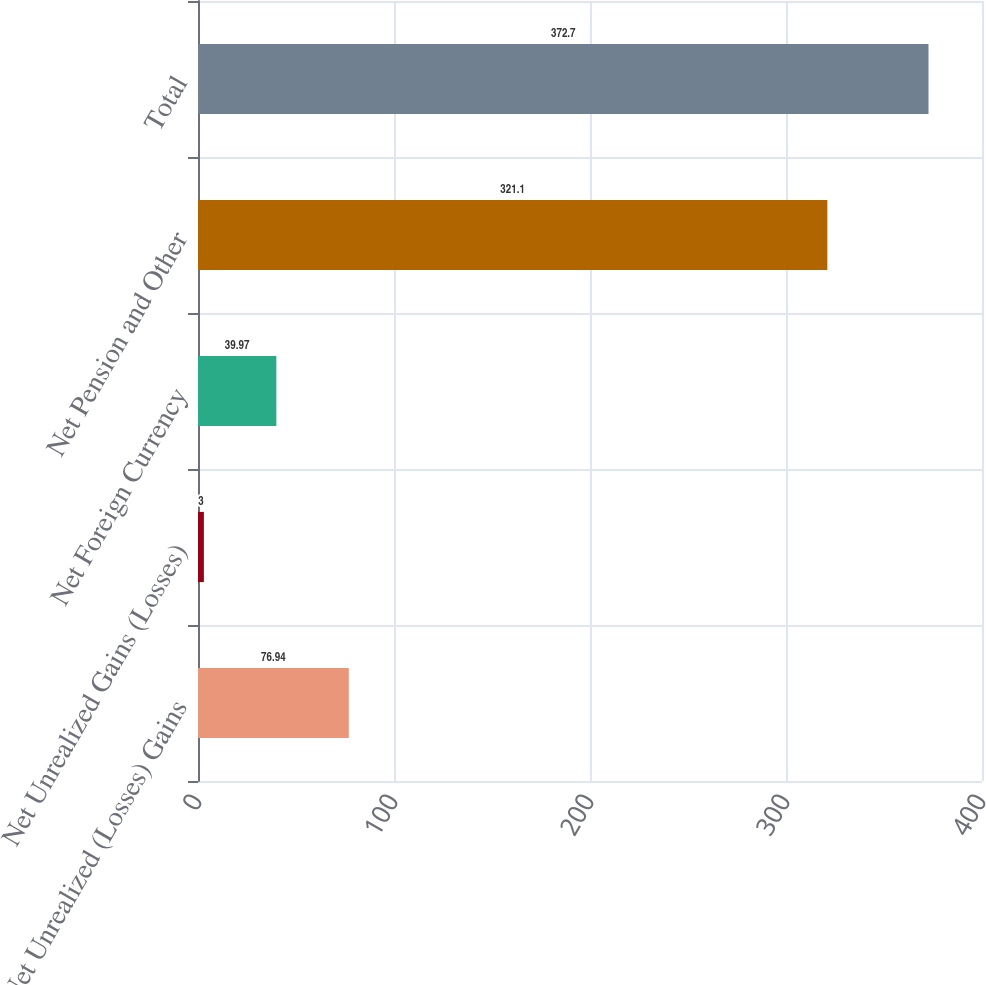Convert chart to OTSL. <chart><loc_0><loc_0><loc_500><loc_500><bar_chart><fcel>Net Unrealized (Losses) Gains<fcel>Net Unrealized Gains (Losses)<fcel>Net Foreign Currency<fcel>Net Pension and Other<fcel>Total<nl><fcel>76.94<fcel>3<fcel>39.97<fcel>321.1<fcel>372.7<nl></chart> 